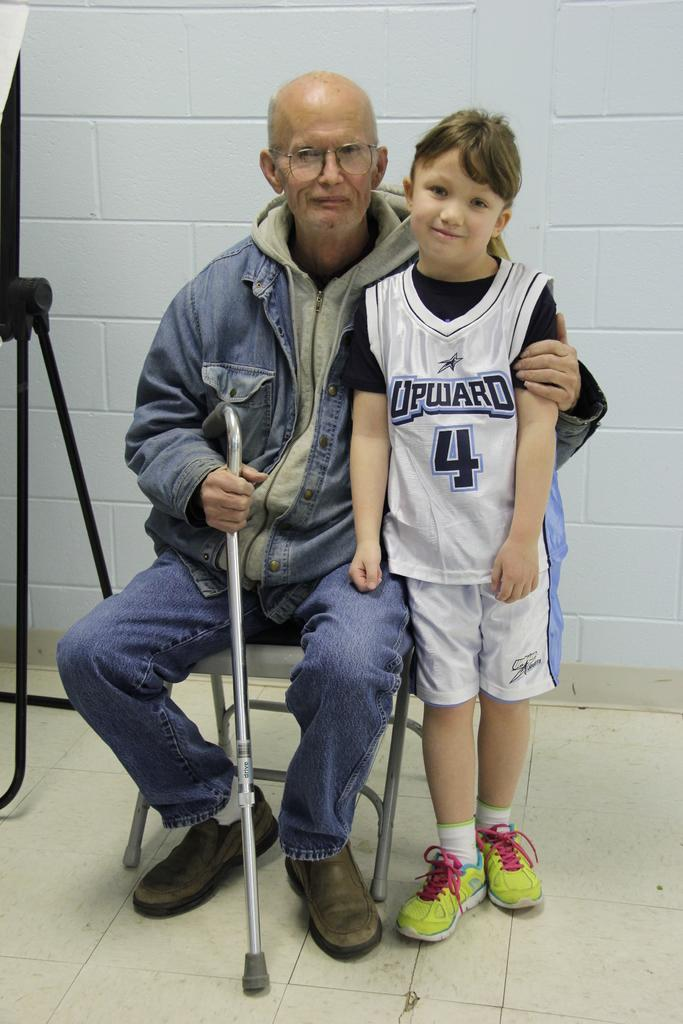Who are the people in the image? There is a man and a boy in the image. What is the man doing in the image? The man is sitting on a chair in the image. What is the man holding in the image? The man is holding a stick in the image. What type of eggnog is being served at the station in the image? There is no station or eggnog present in the image. How does the man feel about holding the stick in the image? The image does not provide information about the man's feelings or emotions. 